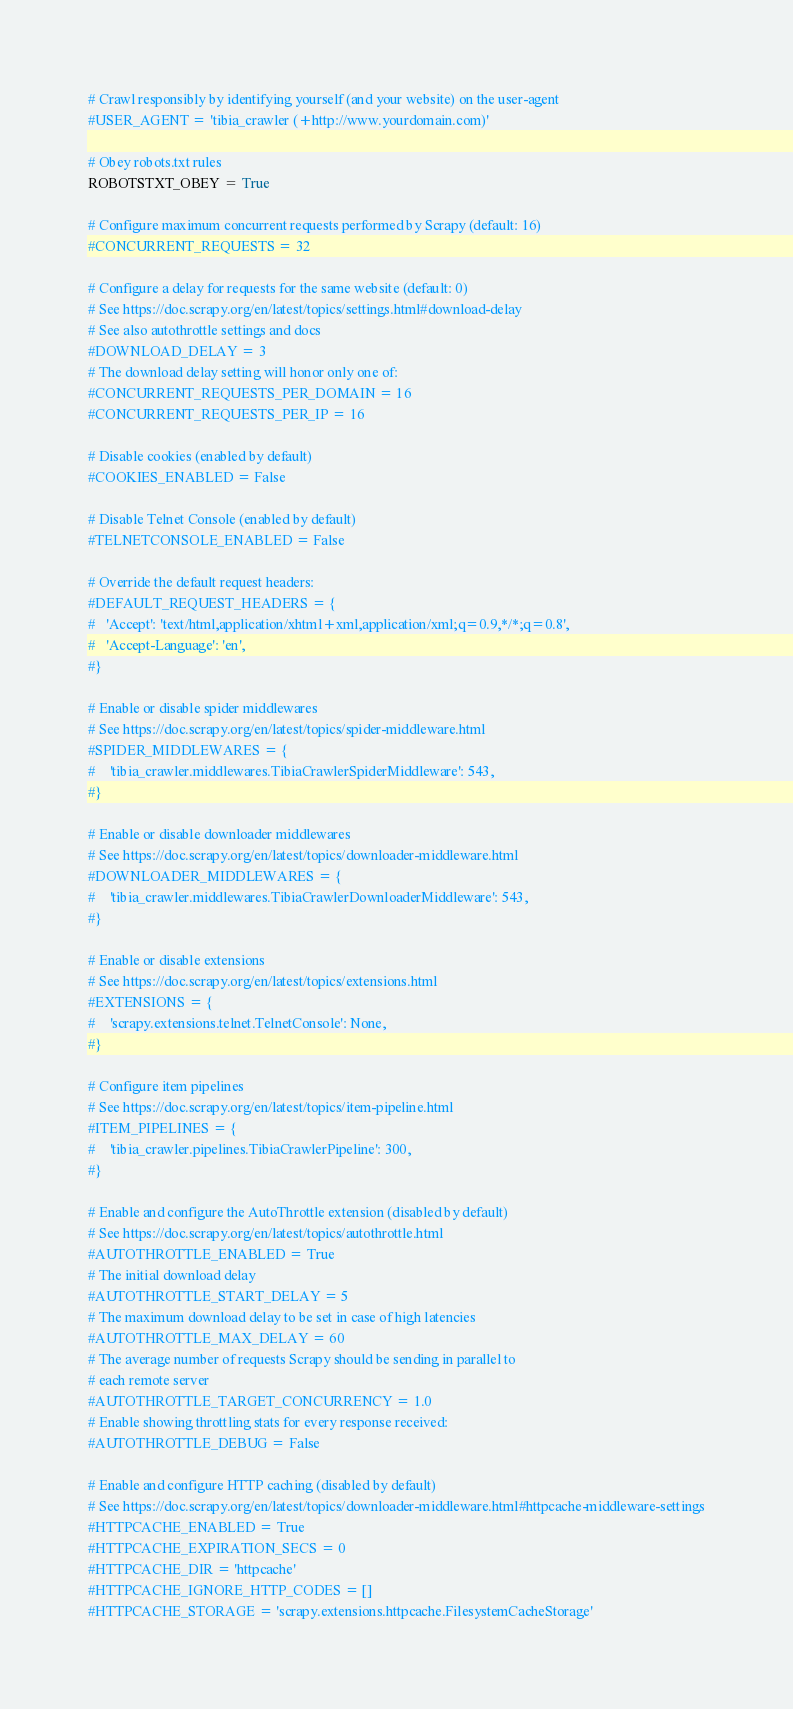<code> <loc_0><loc_0><loc_500><loc_500><_Python_>

# Crawl responsibly by identifying yourself (and your website) on the user-agent
#USER_AGENT = 'tibia_crawler (+http://www.yourdomain.com)'

# Obey robots.txt rules
ROBOTSTXT_OBEY = True

# Configure maximum concurrent requests performed by Scrapy (default: 16)
#CONCURRENT_REQUESTS = 32

# Configure a delay for requests for the same website (default: 0)
# See https://doc.scrapy.org/en/latest/topics/settings.html#download-delay
# See also autothrottle settings and docs
#DOWNLOAD_DELAY = 3
# The download delay setting will honor only one of:
#CONCURRENT_REQUESTS_PER_DOMAIN = 16
#CONCURRENT_REQUESTS_PER_IP = 16

# Disable cookies (enabled by default)
#COOKIES_ENABLED = False

# Disable Telnet Console (enabled by default)
#TELNETCONSOLE_ENABLED = False

# Override the default request headers:
#DEFAULT_REQUEST_HEADERS = {
#   'Accept': 'text/html,application/xhtml+xml,application/xml;q=0.9,*/*;q=0.8',
#   'Accept-Language': 'en',
#}

# Enable or disable spider middlewares
# See https://doc.scrapy.org/en/latest/topics/spider-middleware.html
#SPIDER_MIDDLEWARES = {
#    'tibia_crawler.middlewares.TibiaCrawlerSpiderMiddleware': 543,
#}

# Enable or disable downloader middlewares
# See https://doc.scrapy.org/en/latest/topics/downloader-middleware.html
#DOWNLOADER_MIDDLEWARES = {
#    'tibia_crawler.middlewares.TibiaCrawlerDownloaderMiddleware': 543,
#}

# Enable or disable extensions
# See https://doc.scrapy.org/en/latest/topics/extensions.html
#EXTENSIONS = {
#    'scrapy.extensions.telnet.TelnetConsole': None,
#}

# Configure item pipelines
# See https://doc.scrapy.org/en/latest/topics/item-pipeline.html
#ITEM_PIPELINES = {
#    'tibia_crawler.pipelines.TibiaCrawlerPipeline': 300,
#}

# Enable and configure the AutoThrottle extension (disabled by default)
# See https://doc.scrapy.org/en/latest/topics/autothrottle.html
#AUTOTHROTTLE_ENABLED = True
# The initial download delay
#AUTOTHROTTLE_START_DELAY = 5
# The maximum download delay to be set in case of high latencies
#AUTOTHROTTLE_MAX_DELAY = 60
# The average number of requests Scrapy should be sending in parallel to
# each remote server
#AUTOTHROTTLE_TARGET_CONCURRENCY = 1.0
# Enable showing throttling stats for every response received:
#AUTOTHROTTLE_DEBUG = False

# Enable and configure HTTP caching (disabled by default)
# See https://doc.scrapy.org/en/latest/topics/downloader-middleware.html#httpcache-middleware-settings
#HTTPCACHE_ENABLED = True
#HTTPCACHE_EXPIRATION_SECS = 0
#HTTPCACHE_DIR = 'httpcache'
#HTTPCACHE_IGNORE_HTTP_CODES = []
#HTTPCACHE_STORAGE = 'scrapy.extensions.httpcache.FilesystemCacheStorage'
</code> 